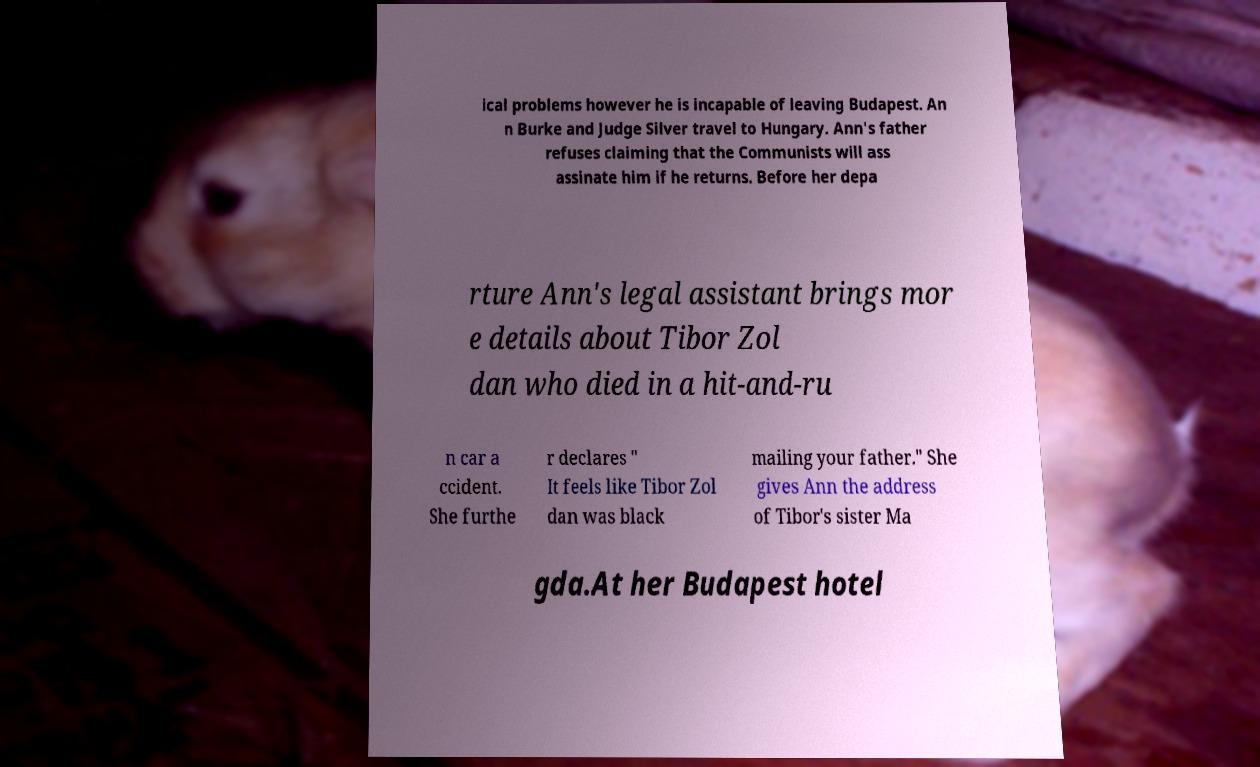Could you extract and type out the text from this image? ical problems however he is incapable of leaving Budapest. An n Burke and Judge Silver travel to Hungary. Ann's father refuses claiming that the Communists will ass assinate him if he returns. Before her depa rture Ann's legal assistant brings mor e details about Tibor Zol dan who died in a hit-and-ru n car a ccident. She furthe r declares " It feels like Tibor Zol dan was black mailing your father." She gives Ann the address of Tibor's sister Ma gda.At her Budapest hotel 